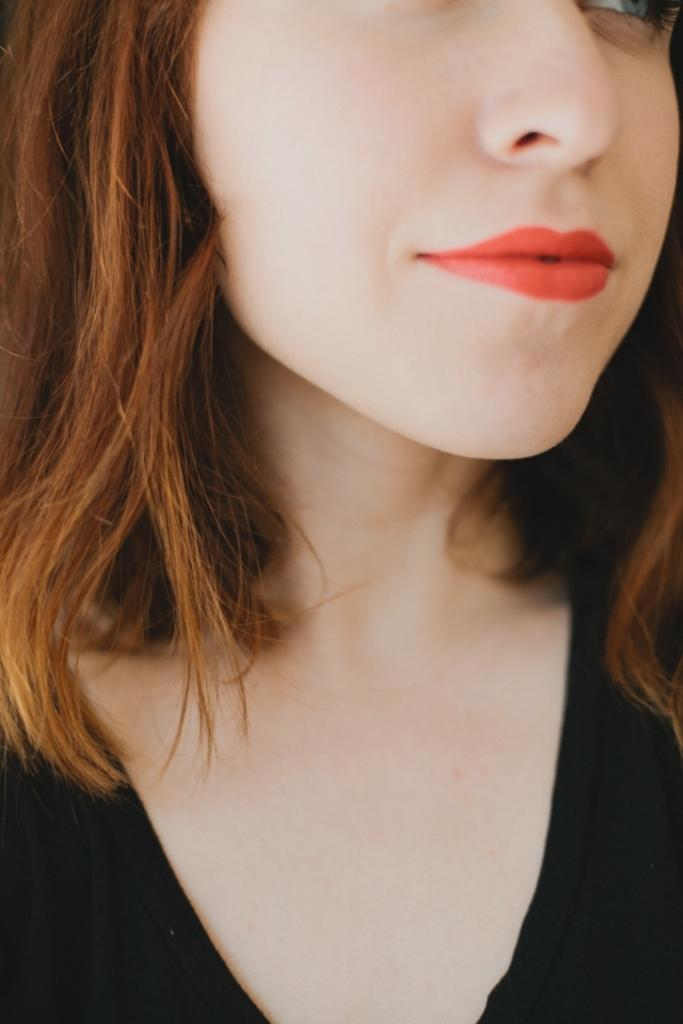Who is the main subject in the image? There is a girl in the image. What is the girl wearing? The girl is wearing a black dress. What cosmetic detail can be observed on the girl's face? The girl has red lipstick on. What is the color of the girl's hair? The girl has brown hair. What type of powder is the girl using to answer questions in the image? There is no powder or question-answering activity present in the image. 